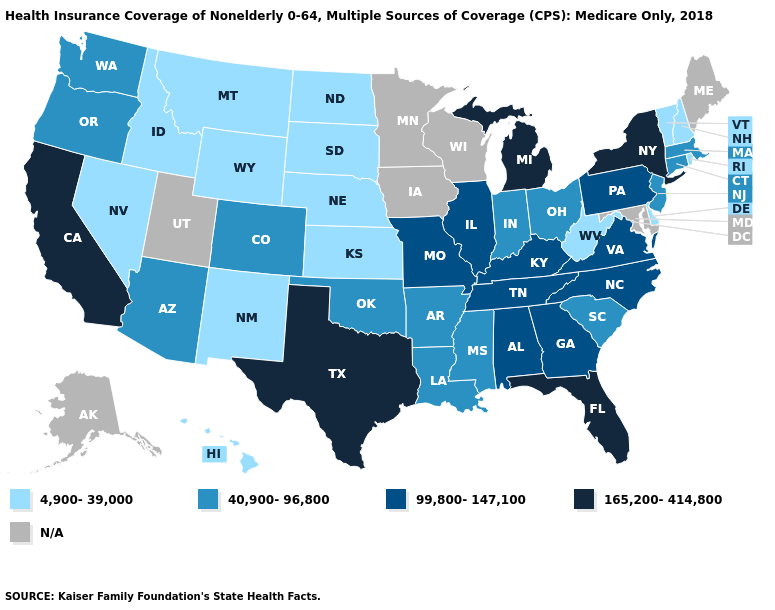What is the highest value in states that border Massachusetts?
Be succinct. 165,200-414,800. Which states have the lowest value in the USA?
Concise answer only. Delaware, Hawaii, Idaho, Kansas, Montana, Nebraska, Nevada, New Hampshire, New Mexico, North Dakota, Rhode Island, South Dakota, Vermont, West Virginia, Wyoming. What is the value of Nebraska?
Answer briefly. 4,900-39,000. Does New York have the highest value in the USA?
Be succinct. Yes. Name the states that have a value in the range 99,800-147,100?
Short answer required. Alabama, Georgia, Illinois, Kentucky, Missouri, North Carolina, Pennsylvania, Tennessee, Virginia. What is the value of Washington?
Quick response, please. 40,900-96,800. What is the highest value in states that border Montana?
Answer briefly. 4,900-39,000. Name the states that have a value in the range 99,800-147,100?
Quick response, please. Alabama, Georgia, Illinois, Kentucky, Missouri, North Carolina, Pennsylvania, Tennessee, Virginia. Which states have the lowest value in the USA?
Write a very short answer. Delaware, Hawaii, Idaho, Kansas, Montana, Nebraska, Nevada, New Hampshire, New Mexico, North Dakota, Rhode Island, South Dakota, Vermont, West Virginia, Wyoming. How many symbols are there in the legend?
Be succinct. 5. Name the states that have a value in the range 4,900-39,000?
Write a very short answer. Delaware, Hawaii, Idaho, Kansas, Montana, Nebraska, Nevada, New Hampshire, New Mexico, North Dakota, Rhode Island, South Dakota, Vermont, West Virginia, Wyoming. Name the states that have a value in the range N/A?
Be succinct. Alaska, Iowa, Maine, Maryland, Minnesota, Utah, Wisconsin. 